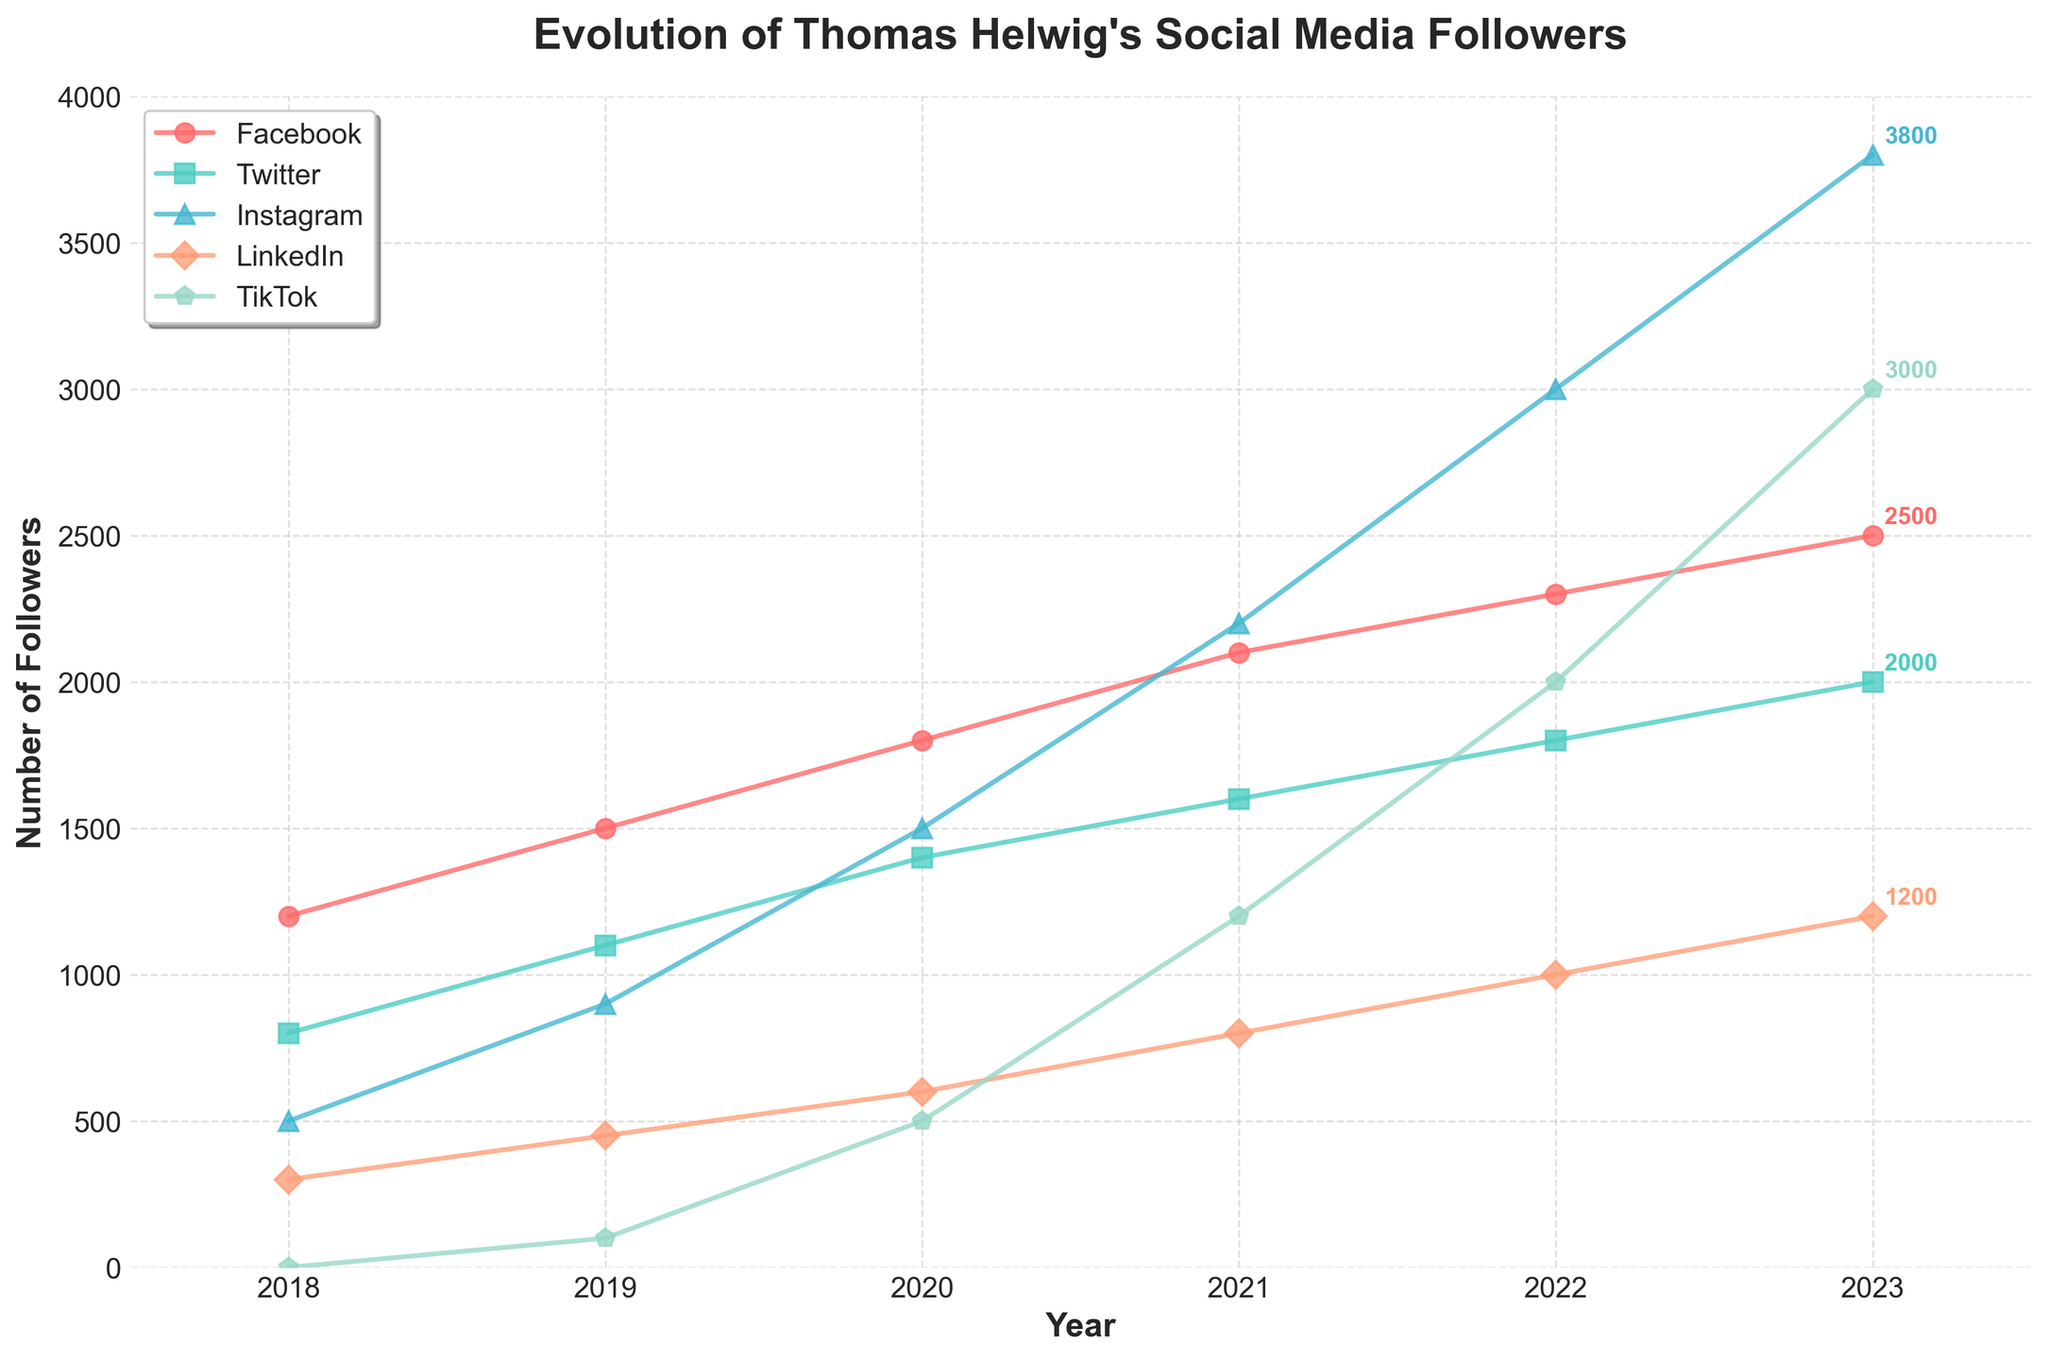What is the difference in the number of Instagram followers between 2019 and 2022? In 2019, there are 900 Instagram followers, and in 2022, there are 3000 Instagram followers. The difference is calculated as 3000 - 900 = 2100.
Answer: 2100 Which year saw the highest increase in TikTok followers? Comparing TikTok follower counts: 2019 (100), 2020 (500), 2021 (1200), 2022 (2000), and 2023 (3000). The highest increase is observed between 2020 and 2021, from 500 to 1200, which is an increase of 700 followers.
Answer: 2021 In which year did LinkedIn followers first exceed 500? Examining the LinkedIn follower counts across the years: 2018 (300), 2019 (450), and 2020 (600). In 2020, the LinkedIn followers first exceed 500.
Answer: 2020 What is the total number of followers across all platforms in 2023? The 2023 followers for each platform are: Facebook (2500), Twitter (2000), Instagram (3800), LinkedIn (1200), and TikTok (3000). Summing these values: 2500 + 2000 + 3800 + 1200 + 3000 = 12500.
Answer: 12500 Which platform had the smallest follower base in 2018? In 2018, the number of followers on each platform are: Facebook (1200), Twitter (800), Instagram (500), LinkedIn (300), and TikTok (0). TikTok had the smallest follower base with 0 followers.
Answer: TikTok How many more Facebook followers were there in 2023 compared to 2021? The number of Facebook followers in 2023 is 2500, and in 2021, it is 2100. The increase is calculated as 2500 - 2100 = 400.
Answer: 400 Which platform experienced the most significant growth in followers from 2018 to 2023? Analyzing the followers from 2018 to 2023 for each platform: Facebook from 1200 to 2500 (+1300), Twitter from 800 to 2000 (+1200), Instagram from 500 to 3800 (+3300), LinkedIn from 300 to 1200 (+900), TikTok from 0 to 3000 (+3000). Instagram experienced the most significant growth with an increase of 3300 followers.
Answer: Instagram What is the average number of Twitter followers from 2018 to 2023? The Twitter follower counts from 2018 to 2023 are: 800, 1100, 1400, 1600, 1800, 2000. The average is calculated as (800 + 1100 + 1400 + 1600 + 1800 + 2000) / 6 = 8700 / 6 = 1450.
Answer: 1450 Between which consecutive years did LinkedIn see the biggest increase in followers? Examining LinkedIn counts: 2018 (300), 2019 (450), 2020 (600), 2021 (800), 2022 (1000), 2023 (1200). The largest consecutive jump is from 2019 to 2020 with an increase of 150 (600 - 450 = 150).
Answer: 2019 to 2020 Which platform's followers showed the least variation between any two consecutive years? Analyzing the differences in followers for each platform between consecutive years, we see that Facebook's followers increased at a steady rate between 2018 to 2023. Specifically, between 2022 and 2023, the increase was the smallest, from 2300 to 2500, which is a difference of 200.
Answer: Facebook 